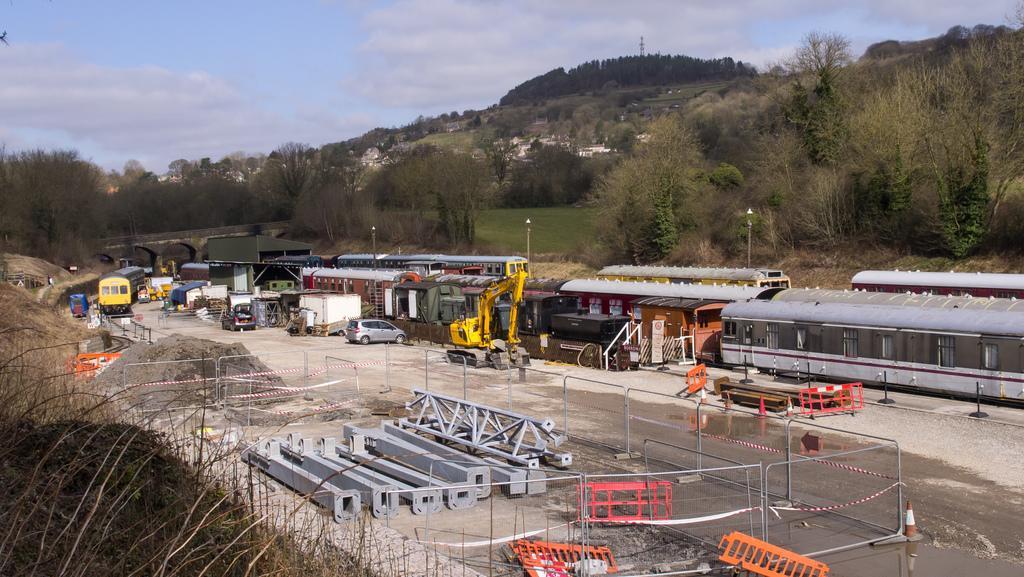Describe this image in one or two sentences. In this image we can see some rods, fence, water, divider poles, mud, trees, train on the track, bridge, houses, cars, backhoe and poles on the land. On the backside we can see some trees, plants, grass, houses on a hill and the sky which looks cloudy. 